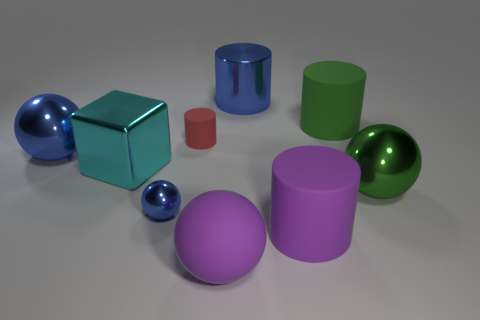Subtract all large blue metallic cylinders. How many cylinders are left? 3 Subtract 1 cylinders. How many cylinders are left? 3 Subtract all purple spheres. How many spheres are left? 3 Subtract all spheres. How many objects are left? 5 Subtract all yellow cubes. How many purple spheres are left? 1 Subtract all big purple balls. Subtract all tiny matte cylinders. How many objects are left? 7 Add 7 small red objects. How many small red objects are left? 8 Add 1 red rubber cylinders. How many red rubber cylinders exist? 2 Subtract 1 blue cylinders. How many objects are left? 8 Subtract all purple spheres. Subtract all red cylinders. How many spheres are left? 3 